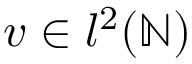Convert formula to latex. <formula><loc_0><loc_0><loc_500><loc_500>v \in l ^ { 2 } ( \mathbb { N } )</formula> 